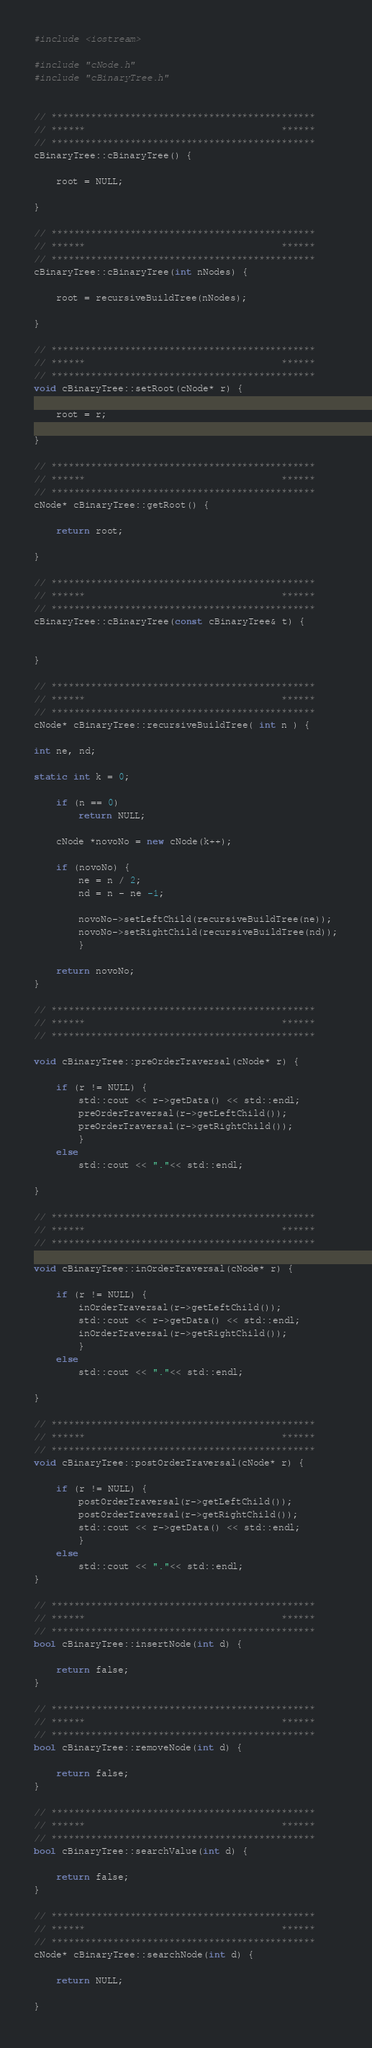<code> <loc_0><loc_0><loc_500><loc_500><_C++_>#include <iostream>

#include "cNode.h"
#include "cBinaryTree.h"


// ***********************************************
// ******                                   ******
// ***********************************************
cBinaryTree::cBinaryTree() {

	root = NULL;

}

// ***********************************************
// ******                                   ******
// ***********************************************
cBinaryTree::cBinaryTree(int nNodes) {

	root = recursiveBuildTree(nNodes);

}

// ***********************************************
// ******                                   ******
// ***********************************************
void cBinaryTree::setRoot(cNode* r) {

	root = r;

}

// ***********************************************
// ******                                   ******
// ***********************************************
cNode* cBinaryTree::getRoot() {

	return root;

}

// ***********************************************
// ******                                   ******
// ***********************************************
cBinaryTree::cBinaryTree(const cBinaryTree& t) {


}

// ***********************************************
// ******                                   ******
// ***********************************************
cNode* cBinaryTree::recursiveBuildTree( int n ) {

int ne, nd;

static int k = 0;

	if (n == 0)
		return NULL;

	cNode *novoNo = new cNode(k++);

	if (novoNo) {
		ne = n / 2;
		nd = n - ne -1;

		novoNo->setLeftChild(recursiveBuildTree(ne));
		novoNo->setRightChild(recursiveBuildTree(nd));
		}

	return novoNo;	
}

// ***********************************************
// ******                                   ******
// ***********************************************

void cBinaryTree::preOrderTraversal(cNode* r) {

	if (r != NULL) {
		std::cout << r->getData() << std::endl;
		preOrderTraversal(r->getLeftChild());
		preOrderTraversal(r->getRightChild());
		}
	else 
		std::cout << "."<< std::endl;	

}

// ***********************************************
// ******                                   ******
// ***********************************************

void cBinaryTree::inOrderTraversal(cNode* r) {

	if (r != NULL) {
		inOrderTraversal(r->getLeftChild());
		std::cout << r->getData() << std::endl;
		inOrderTraversal(r->getRightChild());
		}
	else 
		std::cout << "."<< std::endl;	

}

// ***********************************************
// ******                                   ******
// ***********************************************
void cBinaryTree::postOrderTraversal(cNode* r) {

	if (r != NULL) {
		postOrderTraversal(r->getLeftChild());
		postOrderTraversal(r->getRightChild());
		std::cout << r->getData() << std::endl;
		}
	else 
		std::cout << "."<< std::endl;	
}

// ***********************************************
// ******                                   ******
// ***********************************************	
bool cBinaryTree::insertNode(int d) {

	return false;
}

// ***********************************************
// ******                                   ******
// ***********************************************	
bool cBinaryTree::removeNode(int d) {

	return false;
}

// ***********************************************
// ******                                   ******
// ***********************************************	
bool cBinaryTree::searchValue(int d) {

	return false;
}

// ***********************************************
// ******                                   ******
// ***********************************************	
cNode* cBinaryTree::searchNode(int d) {

	return NULL;

}
</code> 